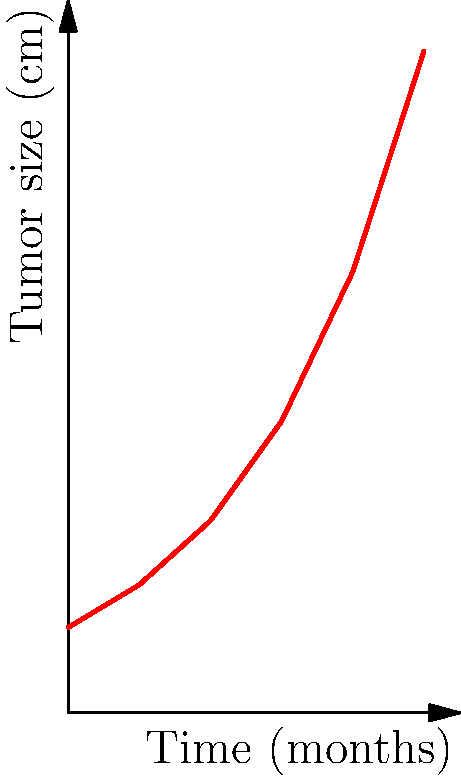A clinical trial is tracking tumor growth in a patient over 5 months. The graph shows the tumor size (in cm) plotted against time (in months). What is the average rate of tumor growth (in cm/month) between points A and B? To find the average rate of tumor growth between points A and B, we need to calculate the slope of the line connecting these two points. The slope represents the change in tumor size per unit of time.

Step 1: Identify the coordinates of points A and B.
Point A: (0, 1.2)
Point B: (5, 9.3)

Step 2: Calculate the change in y (tumor size) and x (time).
Change in y (Δy) = 9.3 - 1.2 = 8.1 cm
Change in x (Δx) = 5 - 0 = 5 months

Step 3: Calculate the slope using the formula:
Slope = Δy / Δx
Slope = 8.1 cm / 5 months = 1.62 cm/month

Therefore, the average rate of tumor growth between points A and B is 1.62 cm/month.
Answer: 1.62 cm/month 